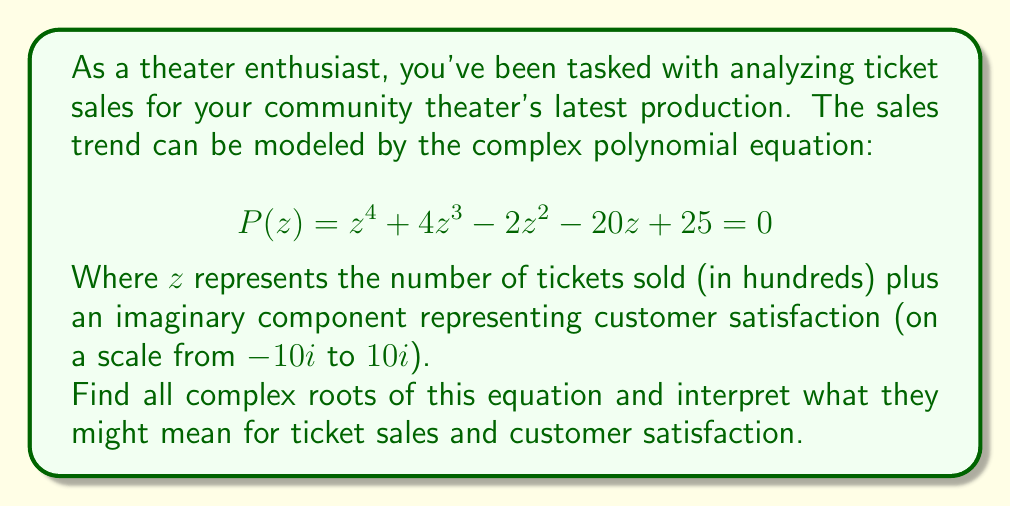Could you help me with this problem? To solve this problem, we'll use the following steps:

1) First, we need to factor the polynomial. This is a 4th-degree polynomial, so it's not immediately factorable by inspection. We can use the rational root theorem to find potential rational roots.

2) The potential rational roots are the factors of the constant term (25): ±1, ±5, ±25.

3) Testing these, we find that 1 and -5 are roots. So we can factor out $(z-1)$ and $(z+5)$:

   $$P(z) = (z-1)(z+5)(z^2 + 0z - 5) = 0$$

4) Now we need to solve the quadratic equation $z^2 - 5 = 0$

5) Using the quadratic formula: $z = \pm\sqrt{5}$

6) Therefore, the four roots are:
   
   $z_1 = 1$
   $z_2 = -5$
   $z_3 = \sqrt{5}i$
   $z_4 = -\sqrt{5}i$

Interpretation:

- $z_1 = 1$: This suggests a scenario of 100 tickets sold with neutral customer satisfaction.
- $z_2 = -5$: This is not a realistic scenario as we can't sell a negative number of tickets.
- $z_3 = \sqrt{5}i \approx 2.24i$: This suggests 0 tickets sold but with a positive customer satisfaction rating of about 2.24 on the -10 to 10 scale.
- $z_4 = -\sqrt{5}i \approx -2.24i$: This suggests 0 tickets sold with a negative customer satisfaction rating of about -2.24.
Answer: The complex roots are: $z_1 = 1$, $z_2 = -5$, $z_3 = \sqrt{5}i$, and $z_4 = -\sqrt{5}i$. 